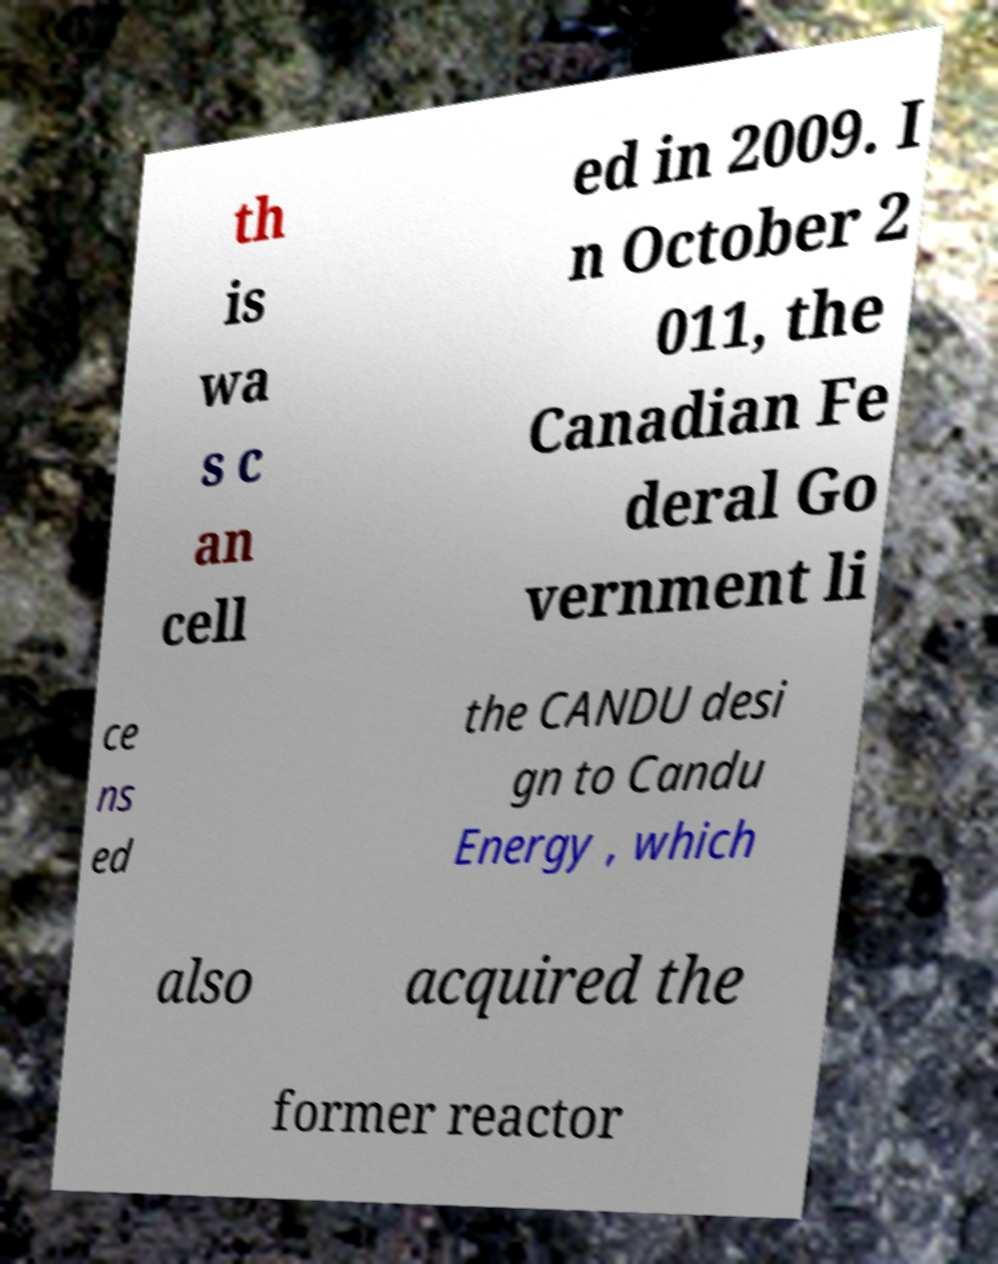There's text embedded in this image that I need extracted. Can you transcribe it verbatim? th is wa s c an cell ed in 2009. I n October 2 011, the Canadian Fe deral Go vernment li ce ns ed the CANDU desi gn to Candu Energy , which also acquired the former reactor 